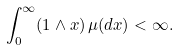Convert formula to latex. <formula><loc_0><loc_0><loc_500><loc_500>\int _ { 0 } ^ { \infty } ( 1 \wedge x ) \, \mu ( d x ) < \infty .</formula> 